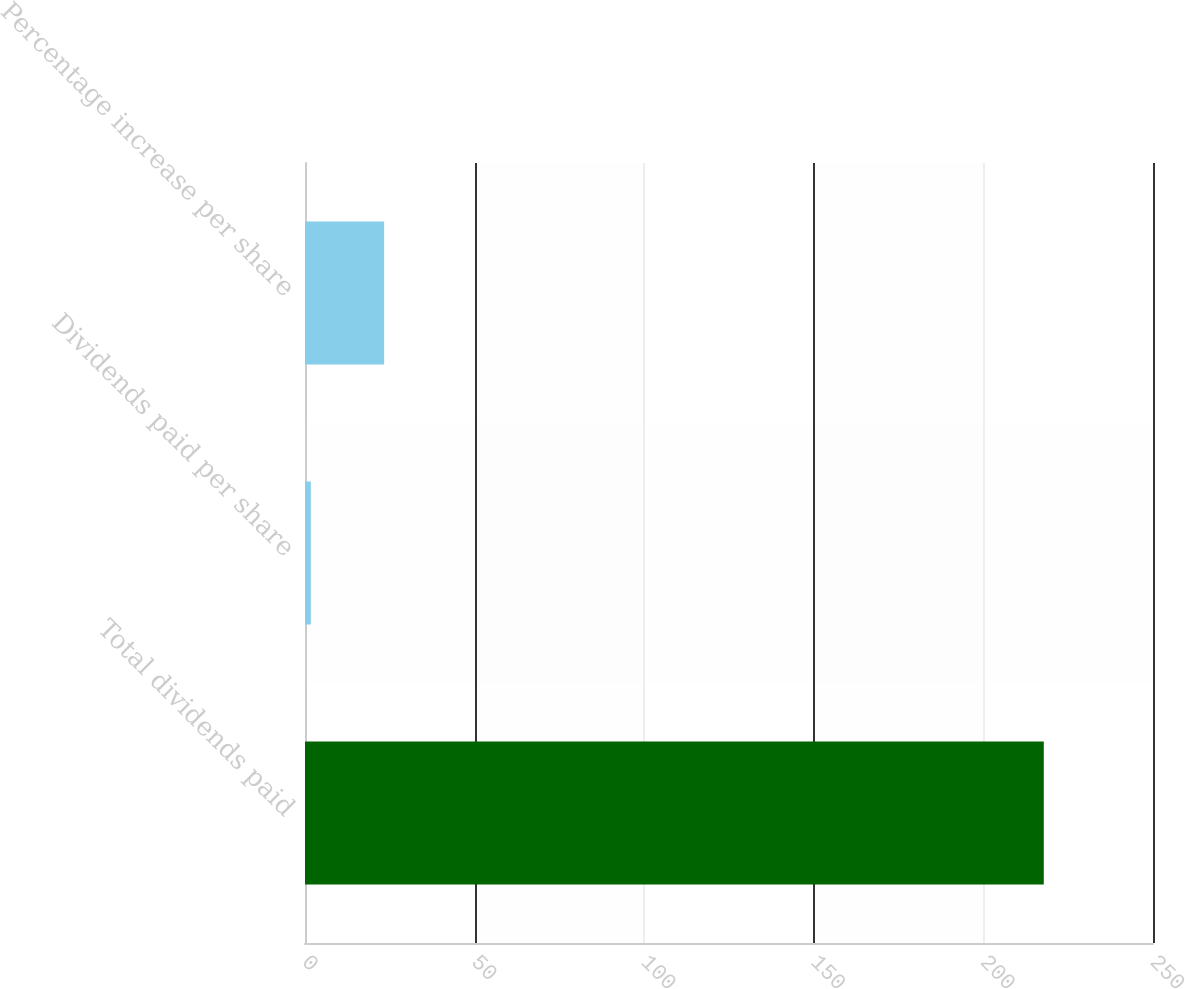Convert chart to OTSL. <chart><loc_0><loc_0><loc_500><loc_500><bar_chart><fcel>Total dividends paid<fcel>Dividends paid per share<fcel>Percentage increase per share<nl><fcel>217.8<fcel>1.72<fcel>23.33<nl></chart> 